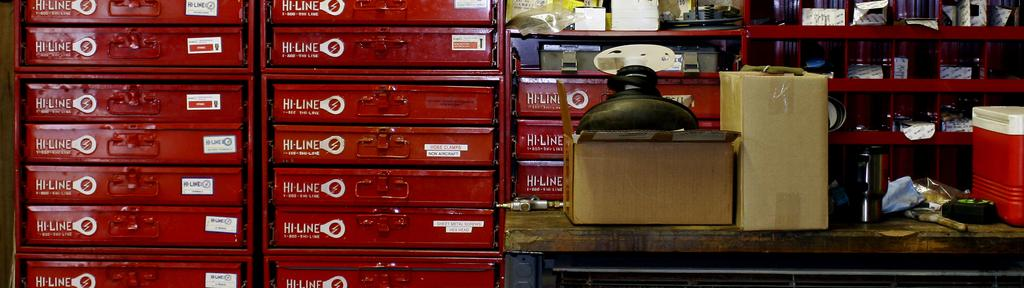<image>
Describe the image concisely. Red trays for Hi-Line in a store with many boxes on the counter. 